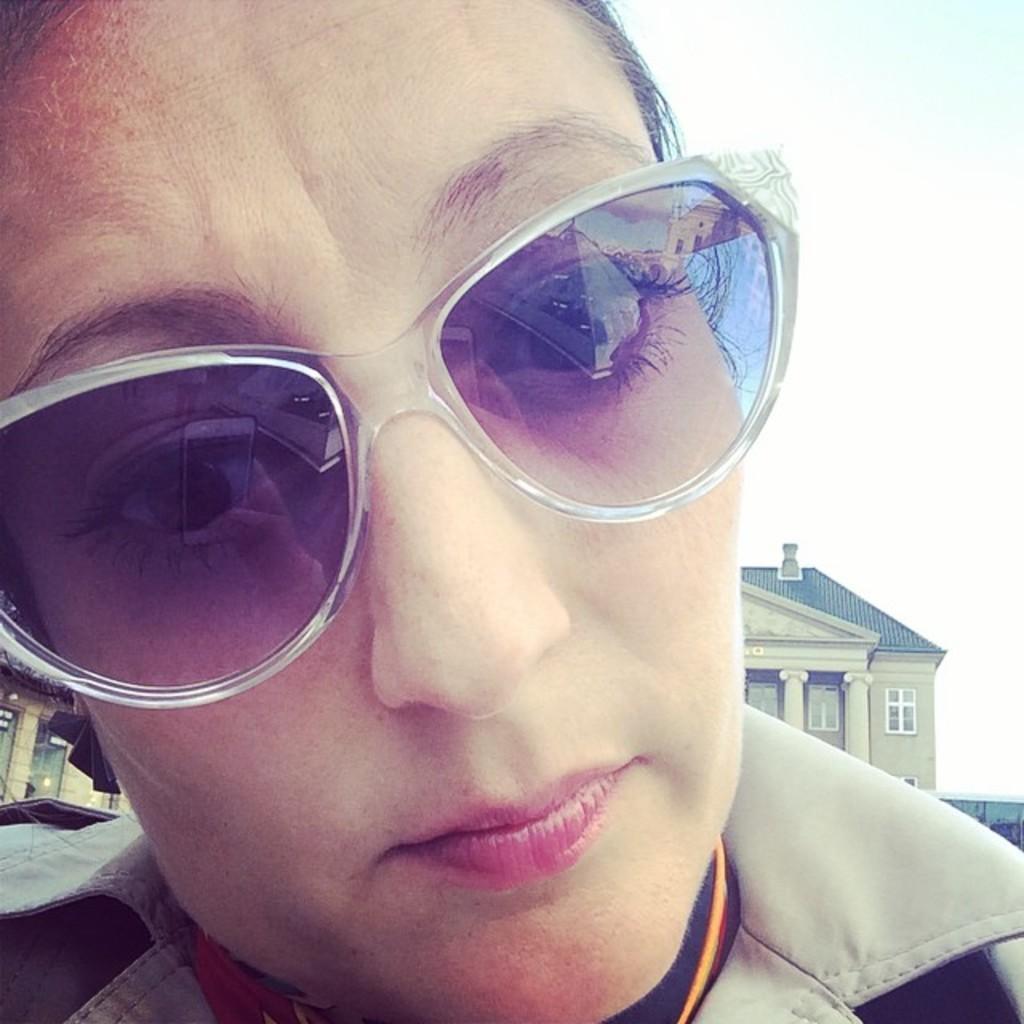How would you summarize this image in a sentence or two? In this picture woman wore sunglasses and I can see buildings in the back and a cloudy sky. 